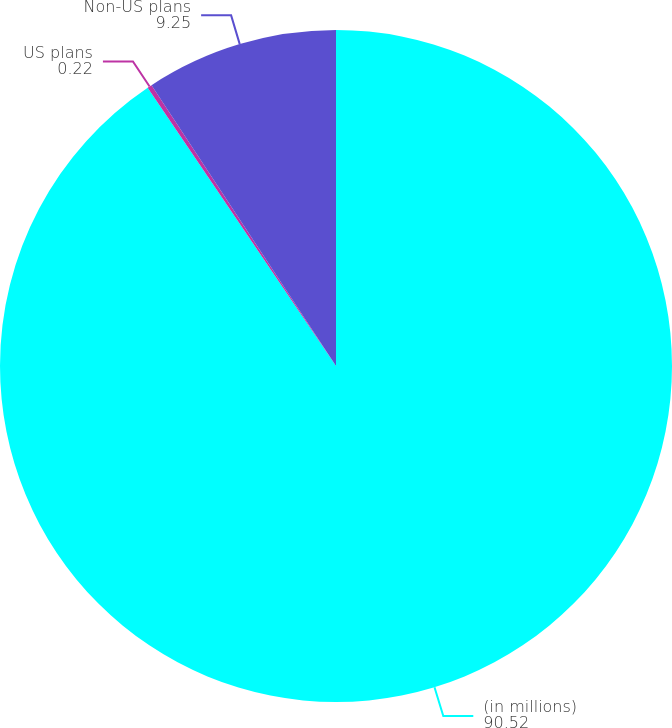Convert chart to OTSL. <chart><loc_0><loc_0><loc_500><loc_500><pie_chart><fcel>(in millions)<fcel>US plans<fcel>Non-US plans<nl><fcel>90.52%<fcel>0.22%<fcel>9.25%<nl></chart> 